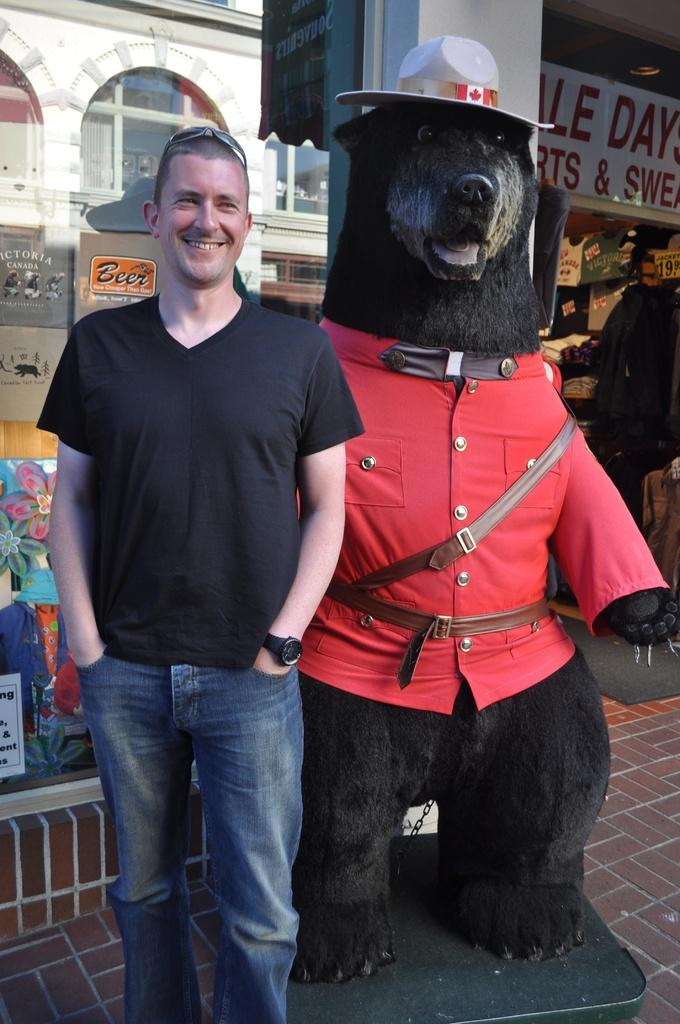What is the person in the image wearing? The person is wearing a black t-shirt and jeans. What can be seen in the background of the image? There is a statue in the background of the image, which is in black and red color. What type of establishments can be seen in the image? There are stores visible in the image. What else is visible in the image besides the person and the statue? There are objects and a banner visible in the image. What type of pear is the person holding in the image? There is no pear present in the image; the person is not holding any fruit. Why is the person crying in the image? The person is not crying in the image; there is no indication of any emotional state. 